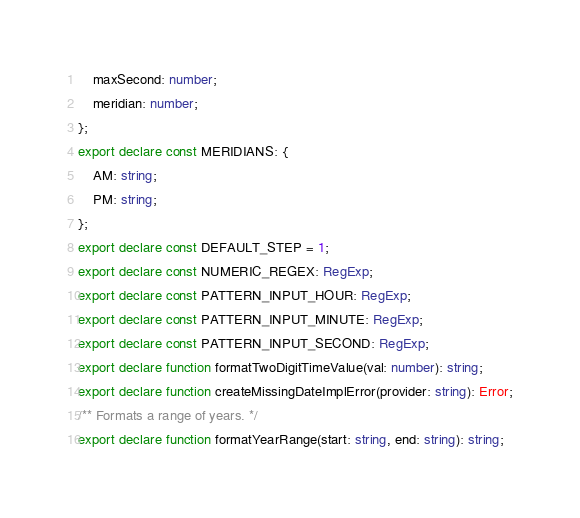Convert code to text. <code><loc_0><loc_0><loc_500><loc_500><_TypeScript_>    maxSecond: number;
    meridian: number;
};
export declare const MERIDIANS: {
    AM: string;
    PM: string;
};
export declare const DEFAULT_STEP = 1;
export declare const NUMERIC_REGEX: RegExp;
export declare const PATTERN_INPUT_HOUR: RegExp;
export declare const PATTERN_INPUT_MINUTE: RegExp;
export declare const PATTERN_INPUT_SECOND: RegExp;
export declare function formatTwoDigitTimeValue(val: number): string;
export declare function createMissingDateImplError(provider: string): Error;
/** Formats a range of years. */
export declare function formatYearRange(start: string, end: string): string;
</code> 